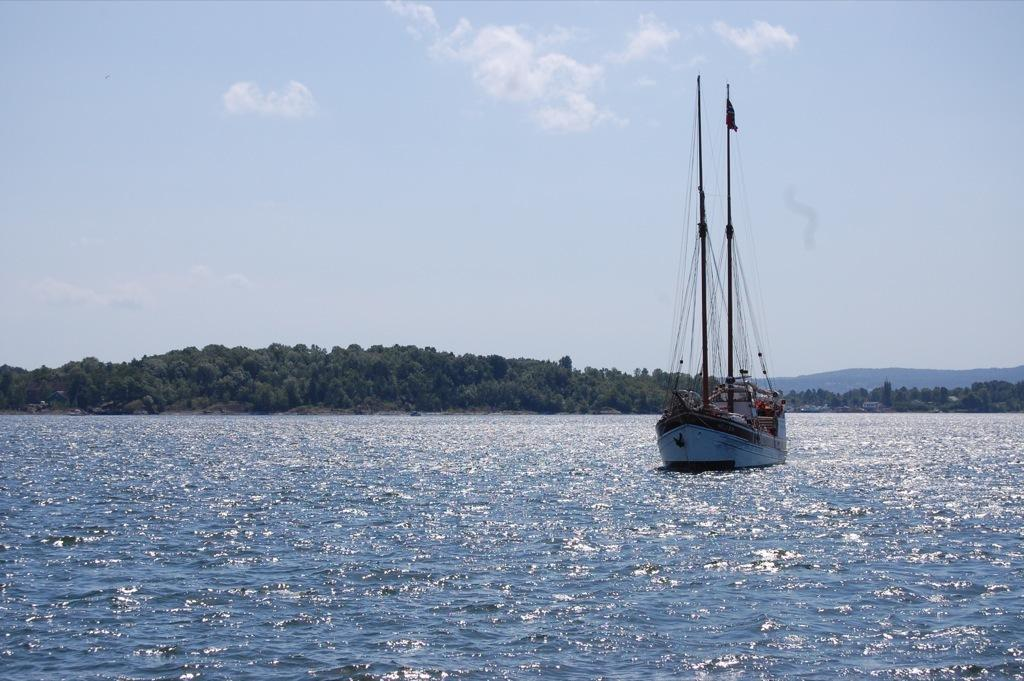What is the main subject of the image? The main subject of the image is a boat. Where is the boat located? The boat is on the water. What can be seen in the background of the image? There are trees and the sky visible in the background of the image. What type of rail is present on the boat in the image? There is no rail present on the boat in the image. On what stage is the boat performing in the image? The image does not depict a stage or performance; it simply shows a boat on the water. 